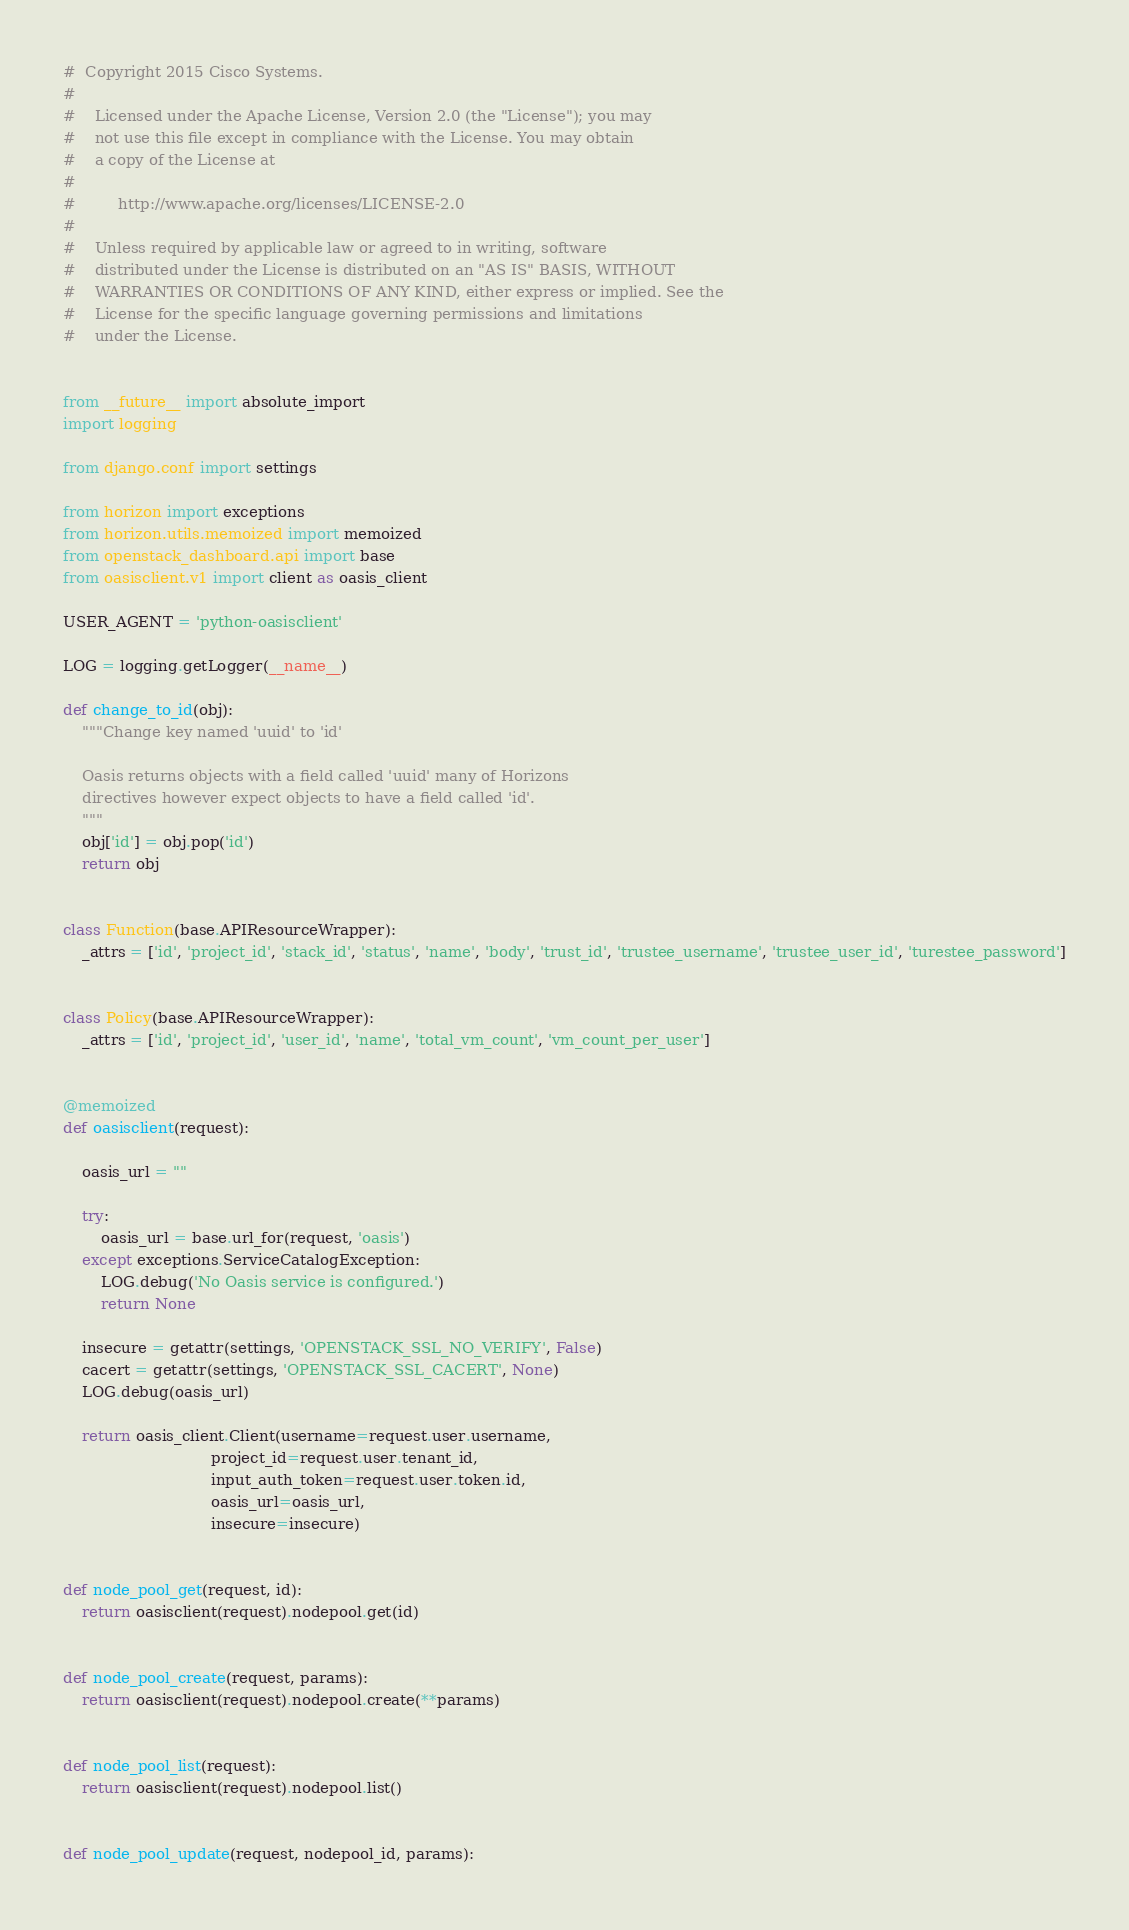Convert code to text. <code><loc_0><loc_0><loc_500><loc_500><_Python_>#  Copyright 2015 Cisco Systems.
#
#    Licensed under the Apache License, Version 2.0 (the "License"); you may
#    not use this file except in compliance with the License. You may obtain
#    a copy of the License at
#
#         http://www.apache.org/licenses/LICENSE-2.0
#
#    Unless required by applicable law or agreed to in writing, software
#    distributed under the License is distributed on an "AS IS" BASIS, WITHOUT
#    WARRANTIES OR CONDITIONS OF ANY KIND, either express or implied. See the
#    License for the specific language governing permissions and limitations
#    under the License.


from __future__ import absolute_import
import logging

from django.conf import settings

from horizon import exceptions
from horizon.utils.memoized import memoized
from openstack_dashboard.api import base
from oasisclient.v1 import client as oasis_client

USER_AGENT = 'python-oasisclient'

LOG = logging.getLogger(__name__)

def change_to_id(obj):
    """Change key named 'uuid' to 'id'

    Oasis returns objects with a field called 'uuid' many of Horizons
    directives however expect objects to have a field called 'id'.
    """
    obj['id'] = obj.pop('id')
    return obj


class Function(base.APIResourceWrapper):
    _attrs = ['id', 'project_id', 'stack_id', 'status', 'name', 'body', 'trust_id', 'trustee_username', 'trustee_user_id', 'turestee_password']


class Policy(base.APIResourceWrapper):
    _attrs = ['id', 'project_id', 'user_id', 'name', 'total_vm_count', 'vm_count_per_user']


@memoized
def oasisclient(request):

    oasis_url = ""

    try:
        oasis_url = base.url_for(request, 'oasis')
    except exceptions.ServiceCatalogException:
        LOG.debug('No Oasis service is configured.')
        return None

    insecure = getattr(settings, 'OPENSTACK_SSL_NO_VERIFY', False)
    cacert = getattr(settings, 'OPENSTACK_SSL_CACERT', None)
    LOG.debug(oasis_url)

    return oasis_client.Client(username=request.user.username,
                               project_id=request.user.tenant_id,
                               input_auth_token=request.user.token.id,
                               oasis_url=oasis_url,
                               insecure=insecure)


def node_pool_get(request, id):
    return oasisclient(request).nodepool.get(id)


def node_pool_create(request, params):
    return oasisclient(request).nodepool.create(**params)


def node_pool_list(request):
    return oasisclient(request).nodepool.list()


def node_pool_update(request, nodepool_id, params):</code> 